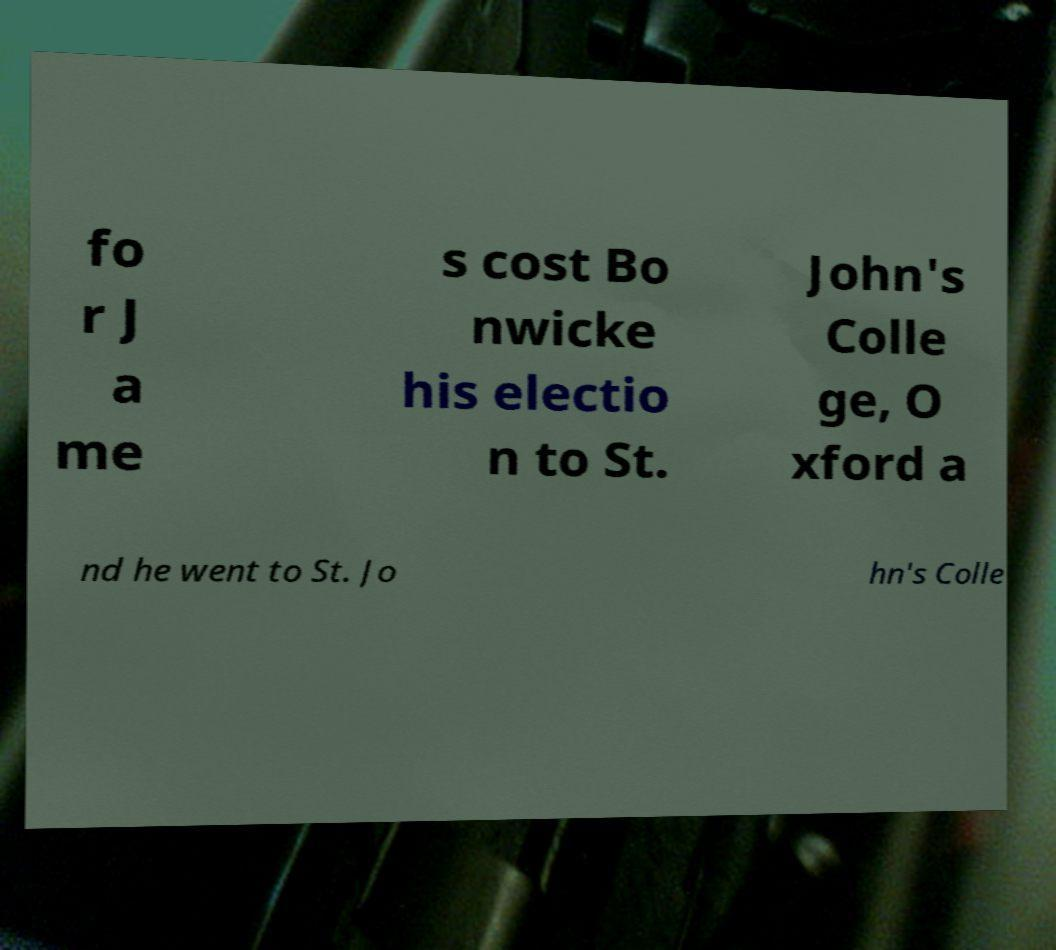What messages or text are displayed in this image? I need them in a readable, typed format. fo r J a me s cost Bo nwicke his electio n to St. John's Colle ge, O xford a nd he went to St. Jo hn's Colle 